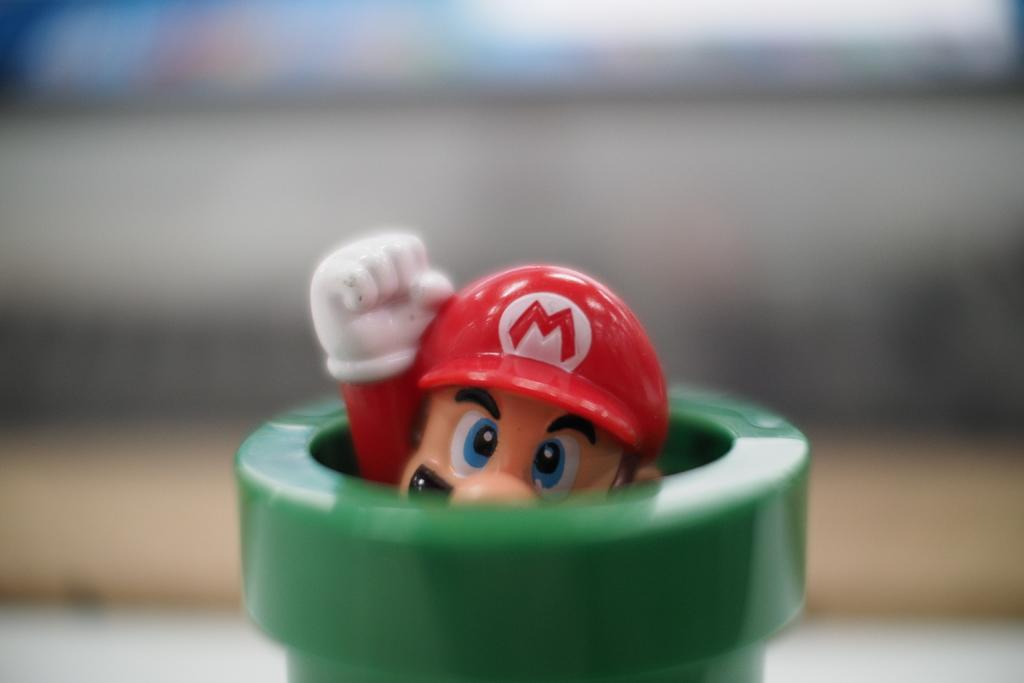What object can be seen in the image? There is a toy in the image. Can you describe the background of the image? The background of the image is blurry. What type of sweater is the manager wearing in the image? There is no manager or sweater present in the image; it only features a toy and a blurry background. 